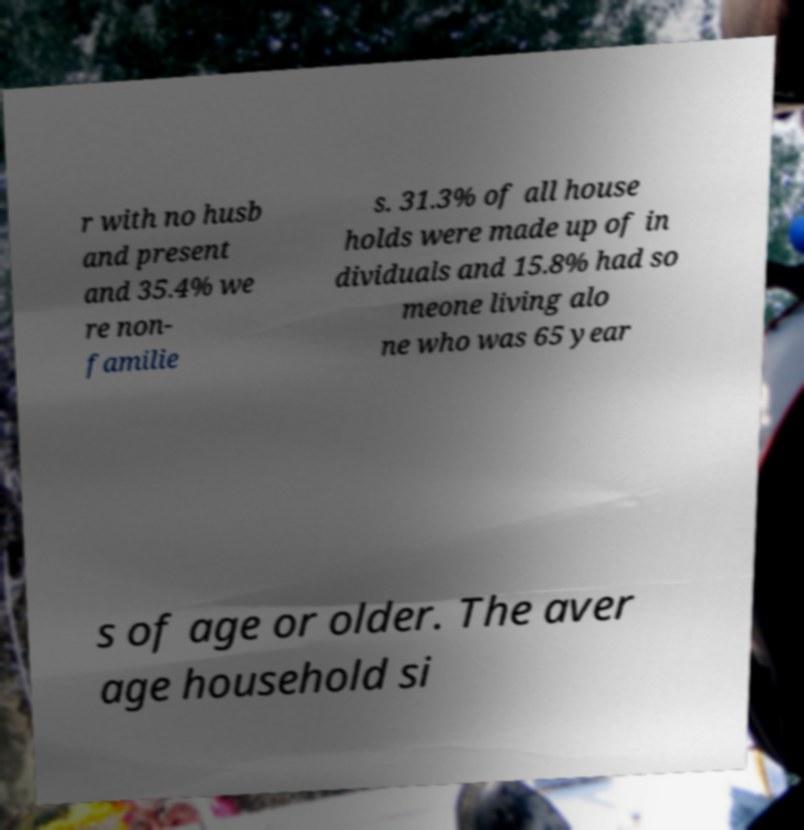Can you read and provide the text displayed in the image?This photo seems to have some interesting text. Can you extract and type it out for me? r with no husb and present and 35.4% we re non- familie s. 31.3% of all house holds were made up of in dividuals and 15.8% had so meone living alo ne who was 65 year s of age or older. The aver age household si 